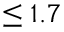<formula> <loc_0><loc_0><loc_500><loc_500>\leq 1 . 7</formula> 